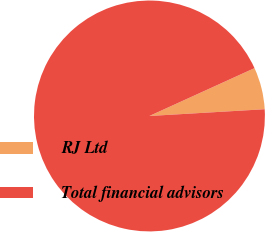<chart> <loc_0><loc_0><loc_500><loc_500><pie_chart><fcel>RJ Ltd<fcel>Total financial advisors<nl><fcel>5.87%<fcel>94.13%<nl></chart> 